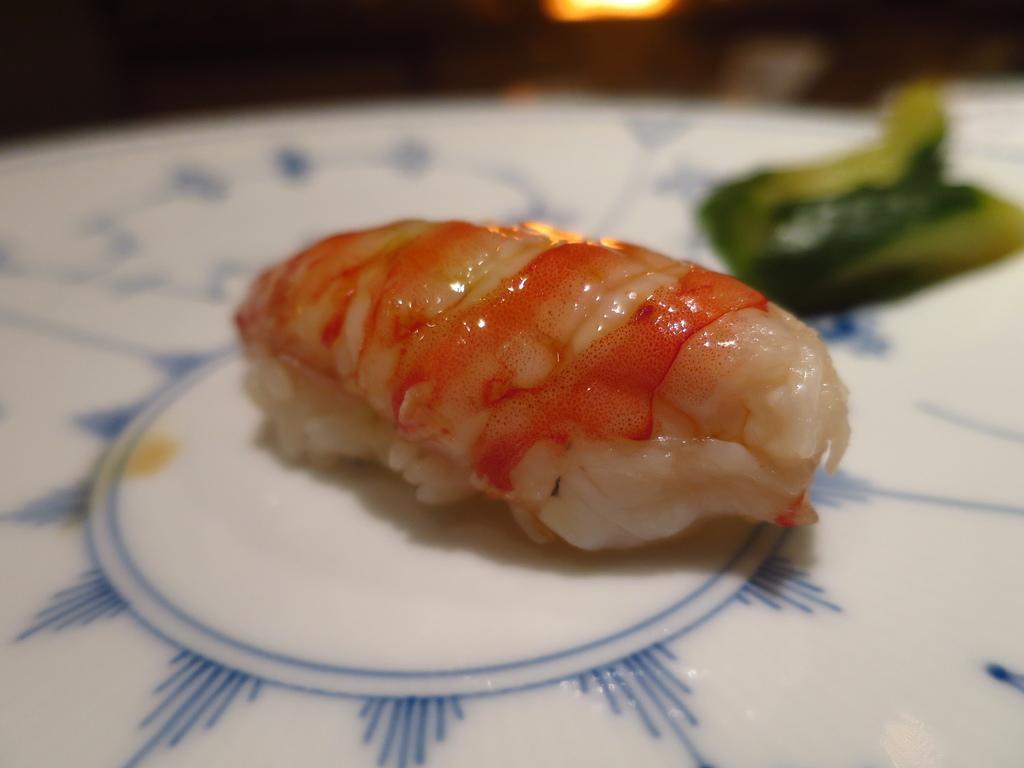Describe this image in one or two sentences. In this image I can see a food on the white color plate. Food is in orange,cream,white and green color. 